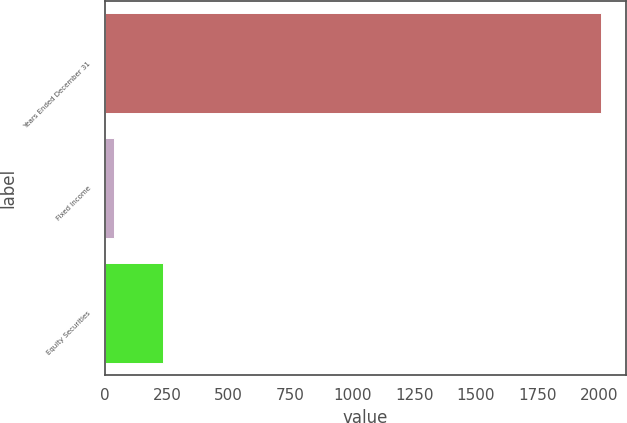<chart> <loc_0><loc_0><loc_500><loc_500><bar_chart><fcel>Years Ended December 31<fcel>Fixed Income<fcel>Equity Securities<nl><fcel>2008<fcel>37<fcel>234.1<nl></chart> 